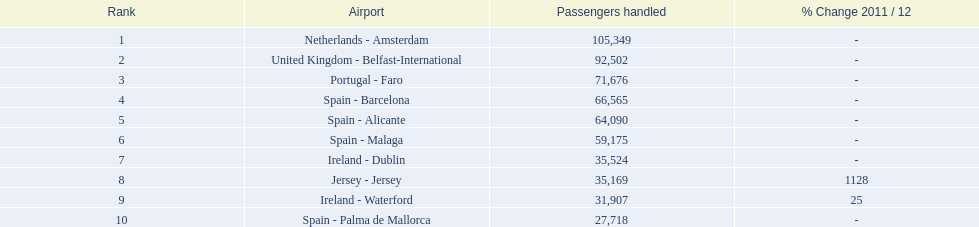Name all the london southend airports that did not list a change in 2001/12. Netherlands - Amsterdam, United Kingdom - Belfast-International, Portugal - Faro, Spain - Barcelona, Spain - Alicante, Spain - Malaga, Ireland - Dublin, Spain - Palma de Mallorca. What unchanged percentage airports from 2011/12 handled less then 50,000 passengers? Ireland - Dublin, Spain - Palma de Mallorca. What unchanged percentage airport from 2011/12 handled less then 50,000 passengers is the closest to the equator? Spain - Palma de Mallorca. 